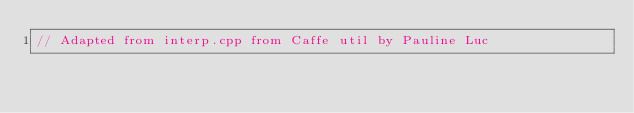<code> <loc_0><loc_0><loc_500><loc_500><_Cuda_>// Adapted from interp.cpp from Caffe util by Pauline Luc</code> 